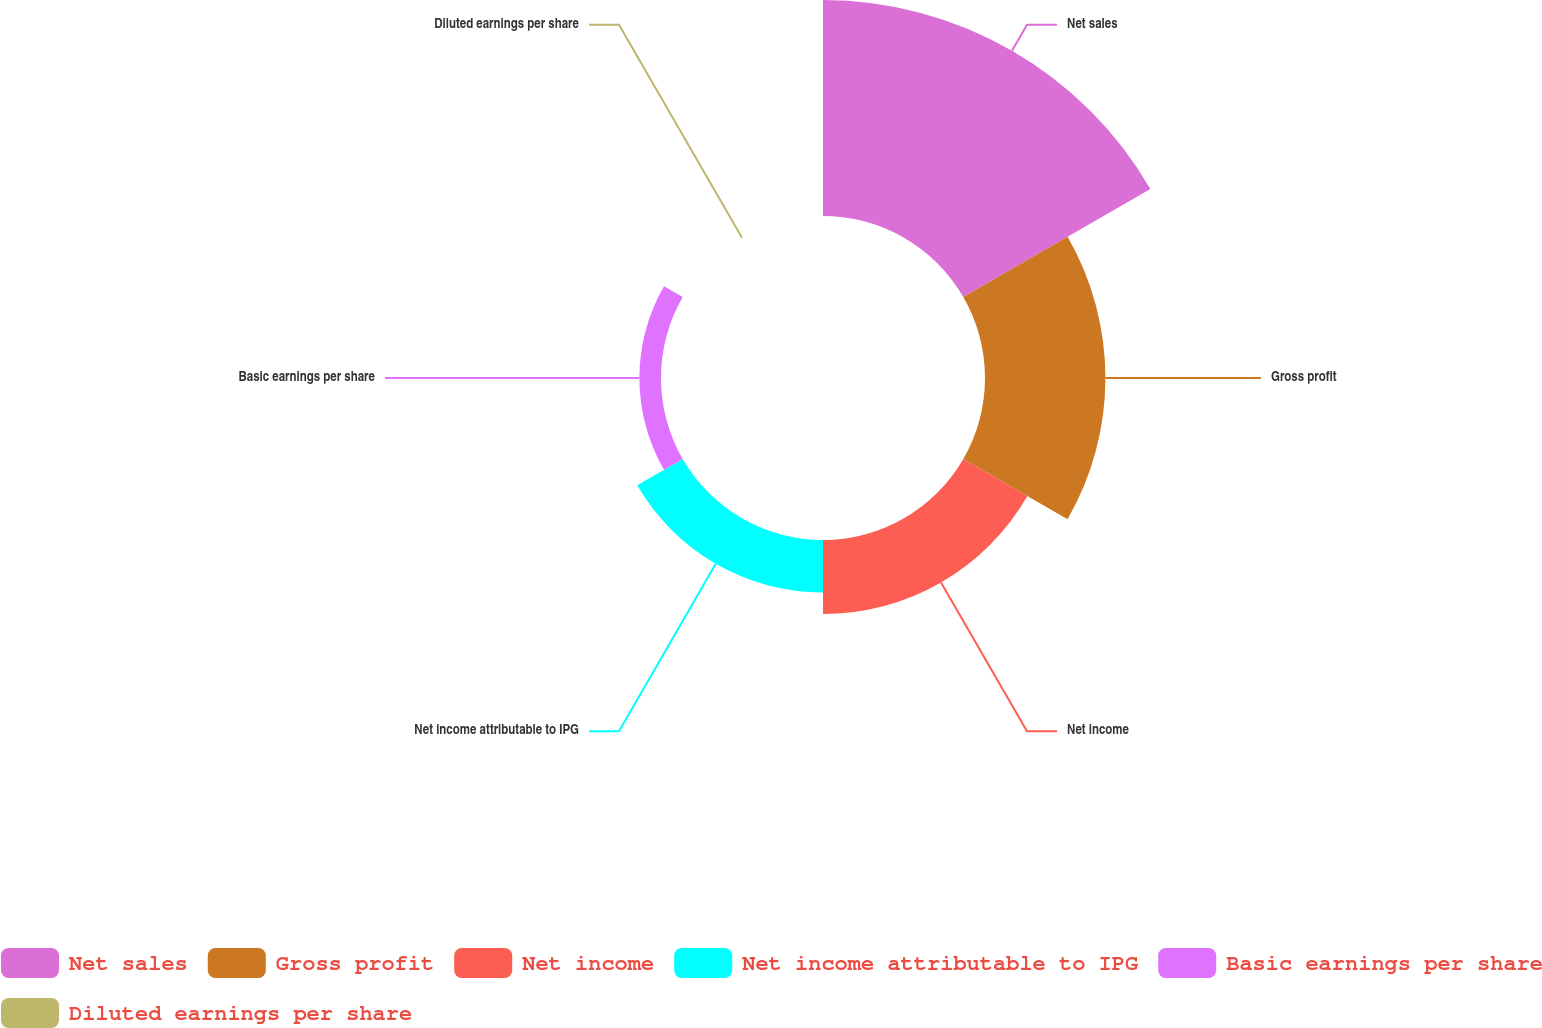<chart> <loc_0><loc_0><loc_500><loc_500><pie_chart><fcel>Net sales<fcel>Gross profit<fcel>Net income<fcel>Net income attributable to IPG<fcel>Basic earnings per share<fcel>Diluted earnings per share<nl><fcel>44.58%<fcel>24.85%<fcel>15.28%<fcel>10.83%<fcel>4.46%<fcel>0.0%<nl></chart> 